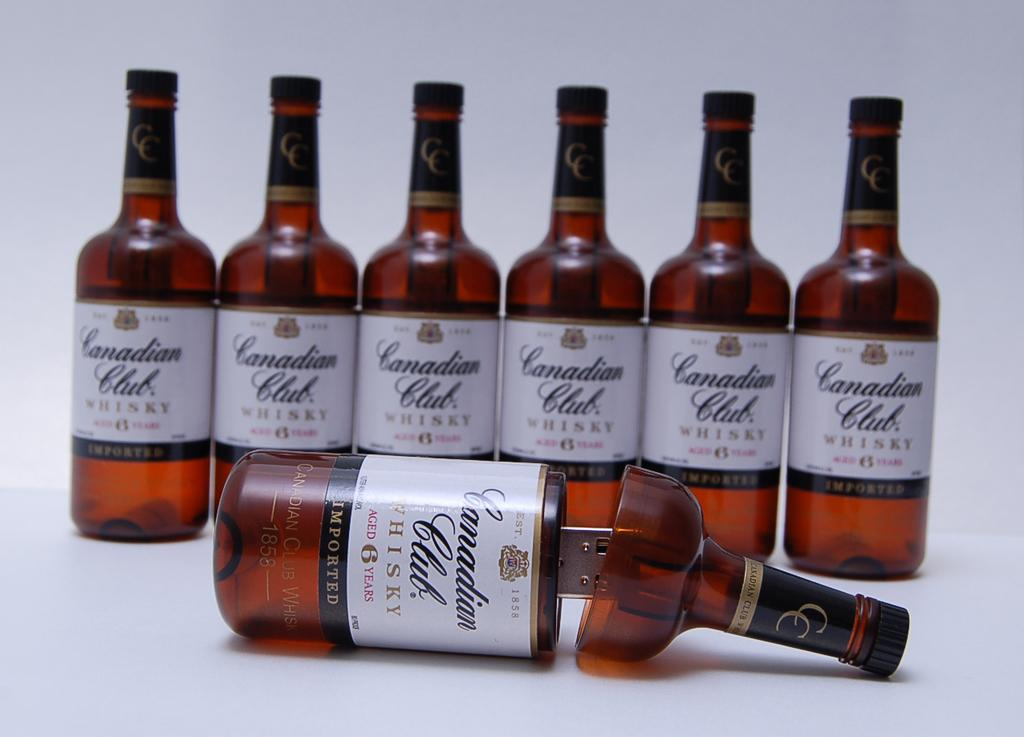Provide a one-sentence caption for the provided image. The imported whisky is from Canadian Club Whisky. 